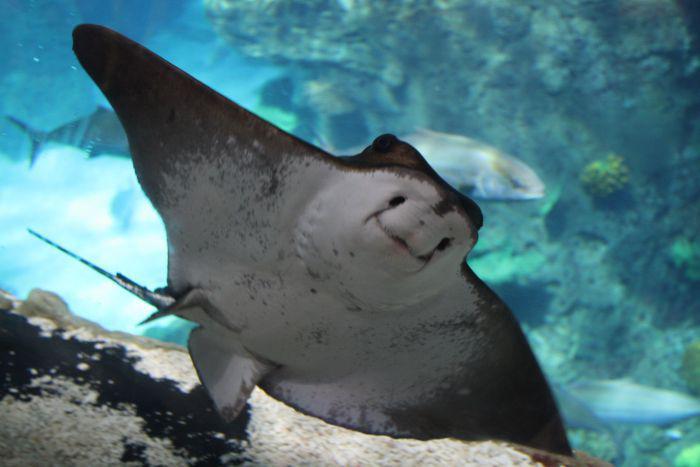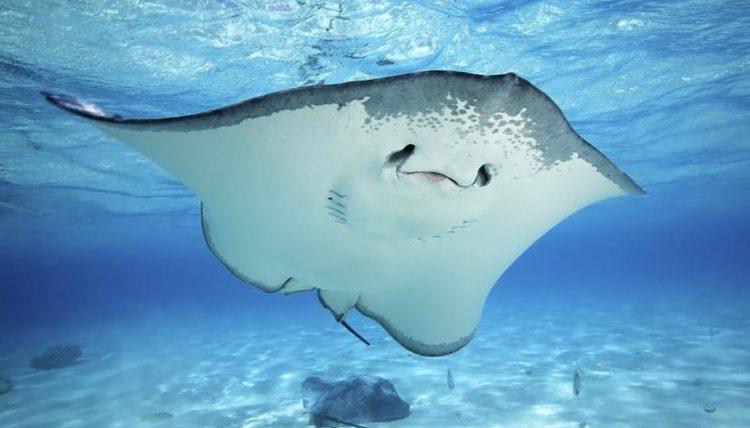The first image is the image on the left, the second image is the image on the right. Examine the images to the left and right. Is the description "Two stingrays are swimming on the floor of the sea in the image on the right." accurate? Answer yes or no. No. 